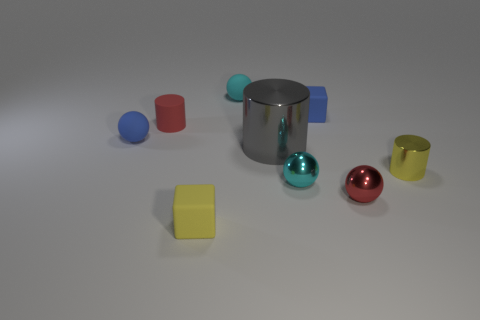Subtract all red balls. How many balls are left? 3 Subtract 1 balls. How many balls are left? 3 Subtract all brown balls. Subtract all purple cubes. How many balls are left? 4 Subtract all spheres. How many objects are left? 5 Subtract 0 green cylinders. How many objects are left? 9 Subtract all small blue matte blocks. Subtract all rubber spheres. How many objects are left? 6 Add 2 blue matte things. How many blue matte things are left? 4 Add 3 tiny cyan metal balls. How many tiny cyan metal balls exist? 4 